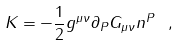Convert formula to latex. <formula><loc_0><loc_0><loc_500><loc_500>K = - \frac { 1 } { 2 } g ^ { \mu \nu } \partial _ { P } G _ { \mu \nu } n ^ { P } \ ,</formula> 